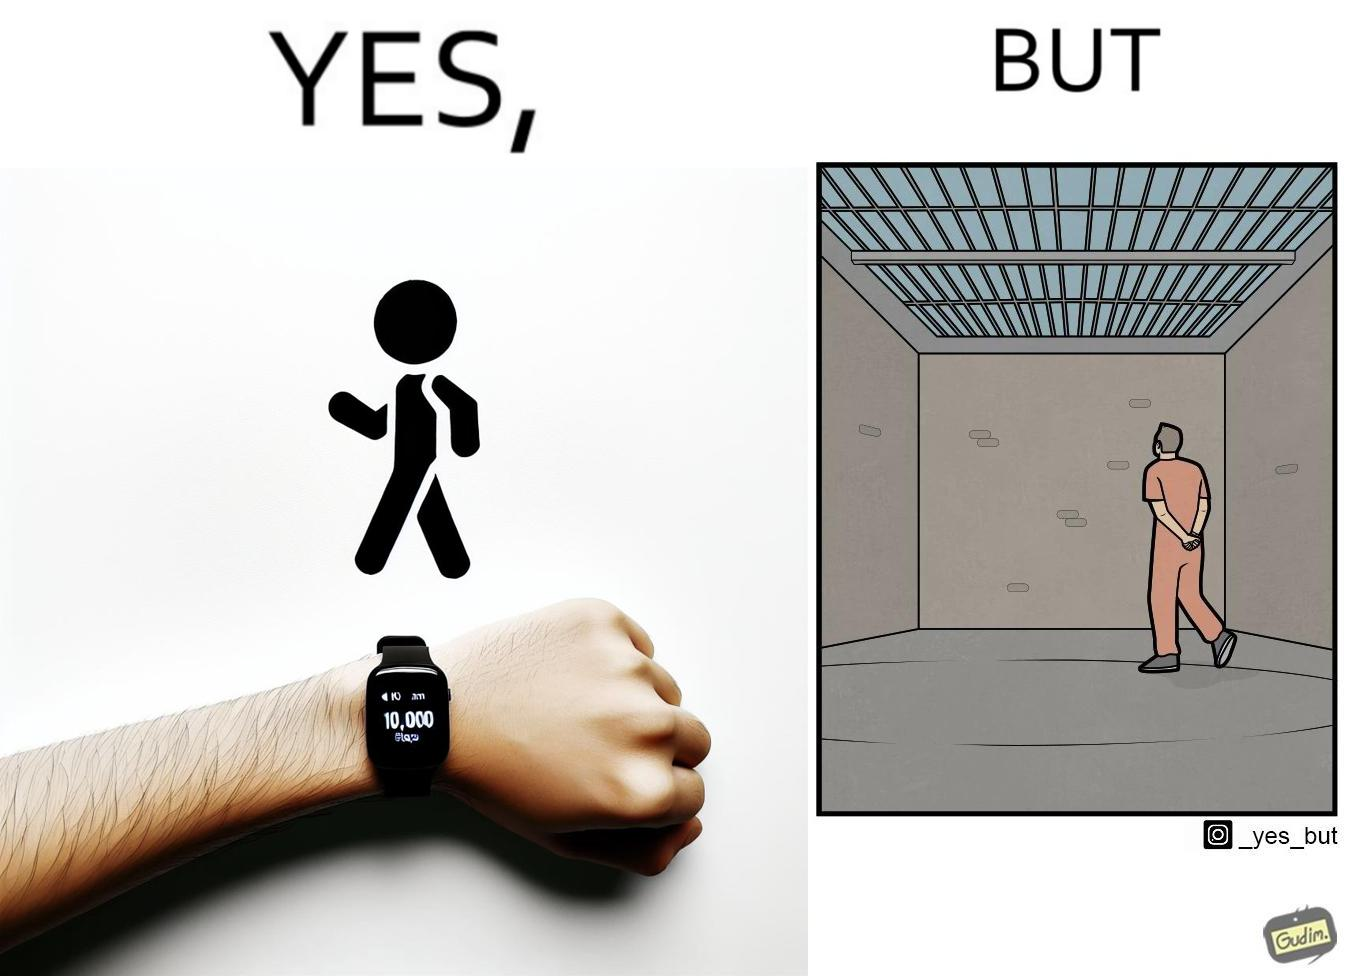Describe the content of this image. The image is ironical, as the smartwatch on the person's wrist shows 10,000 steps completed as an accomplishment, while showing later that the person is apparently walking inside a jail as a prisoner. 